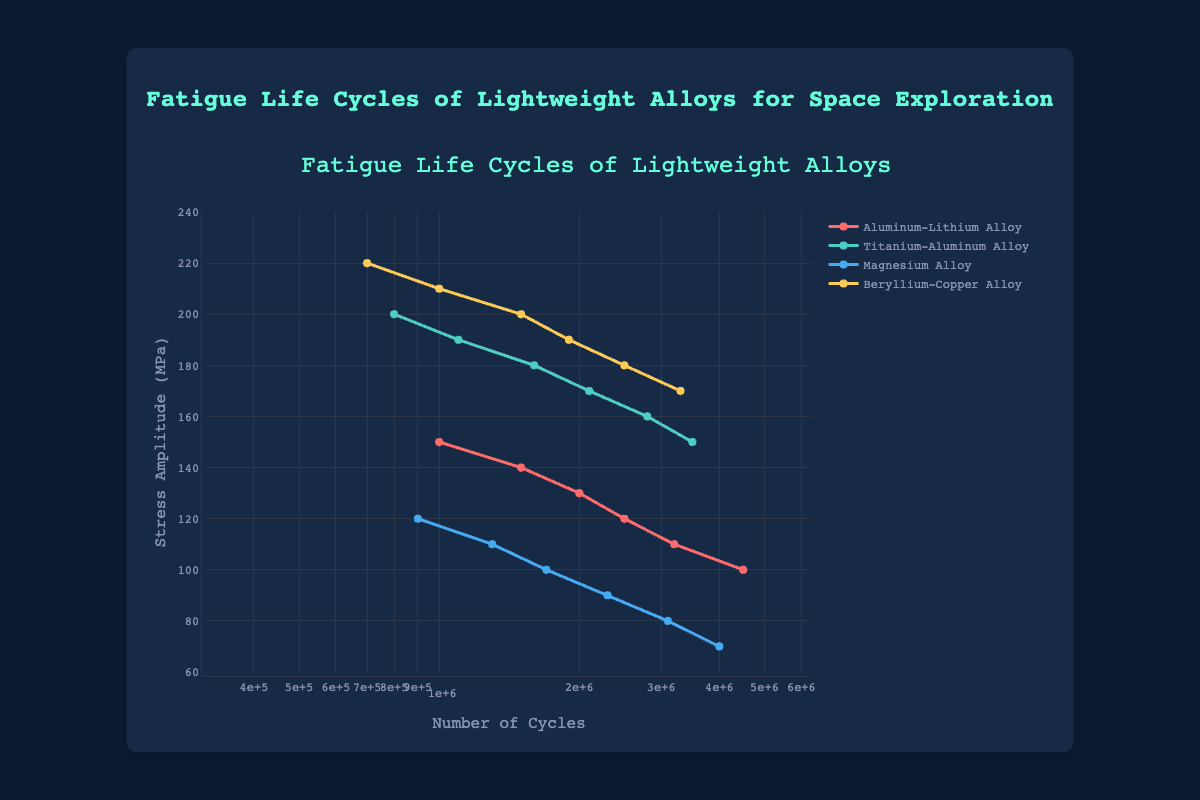Which material demonstrates the highest number of cycles at a stress amplitude of 150 MPa? To answer this, locate the data points for a stress amplitude of 150 MPa for each material and compare their number of cycles. The Aluminum-Lithium Alloy has 1,000,000 cycles, the Titanium-Aluminum Alloy has 3,500,000 cycles, the Magnesium Alloy does not have a data point for 150 MPa, and the Beryllium-Copper Alloy has 700,000 cycles. Hence, the Titanium-Aluminum Alloy demonstrates the highest number of cycles at 150 MPa.
Answer: Titanium-Aluminum Alloy What is the trend in the stress amplitude as the number of cycles increases for the Aluminum-Lithium Alloy? To determine the trend, examine the plotted data points of the Aluminum-Lithium Alloy. As the number of cycles increases from 1,000,000 to 4,500,000, the stress amplitude decreases from 150 MPa to 100 MPa, indicating a downward trend.
Answer: Downward Which material can withstand the highest stress amplitude for a given number of cycles? To find out, compare the stress amplitudes for each material at comparable numbers of cycles. Across the plotted data, the Beryllium-Copper Alloy can withstand the highest stress amplitude; for example, at 1,500,000 cycles, its stress amplitude is 200 MPa compared to lower values for the other materials.
Answer: Beryllium-Copper Alloy At 1,000,000 cycles, which material shows the lowest stress amplitude and what is its value? Examine the plotted points corresponding to 1,000,000 cycles for each material. The stress amplitudes are 150 MPa for Aluminum-Lithium Alloy, 190 MPa for Titanium-Aluminum Alloy, 110 MPa for Magnesium Alloy, and 210 MPa for Beryllium-Copper Alloy. The Magnesium Alloy has the lowest stress amplitude at 1,000,000 cycles, with a value of 110 MPa.
Answer: Magnesium Alloy (110 MPa) How does the number of cycles at a stress amplitude of 90 MPa compare between the Magnesium Alloy and the Beryllium-Copper Alloy? First, identify the number of cycles for each material at 90 MPa. The Magnesium Alloy has 2,300,000 cycles, while the Beryllium-Copper Alloy does not have a data point at 90 MPa. Thus, the Magnesium Alloy can be compared directly, whereas the Beryllium-Copper Alloy cannot.
Answer: Only Magnesium Alloy is available (2,300,000 cycles) What's the average number of cycles for Aluminum-Lithium Alloy across all provided stress amplitudes? To find this, compute the sum and average of the number of cycles for the Aluminum-Lithium Alloy data points: (1,000,000 + 1,500,000 + 2,000,000 + 2,500,000 + 3,200,000 + 4,500,000) = 14,700,000. The average is 14,700,000 / 6 = 2,450,000.
Answer: 2,450,000 What color represents the Titanium-Aluminum Alloy in the plot? Observe the legend in the plot to identify the color associated with the Titanium-Aluminum Alloy. It is represented by the color green (second in the list).
Answer: Green Which material exhibits the steepest decline in stress amplitude as the number of cycles increases? Compare the slopes of the lines representing each material. The steepest decline can be visually identified by the sharpness of the drop in stress amplitude with increasing cycles. The Beryllium-Copper Alloy displays the steepest decline due to its high initial stress amplitude and rapid decrease.
Answer: Beryllium-Copper Alloy 